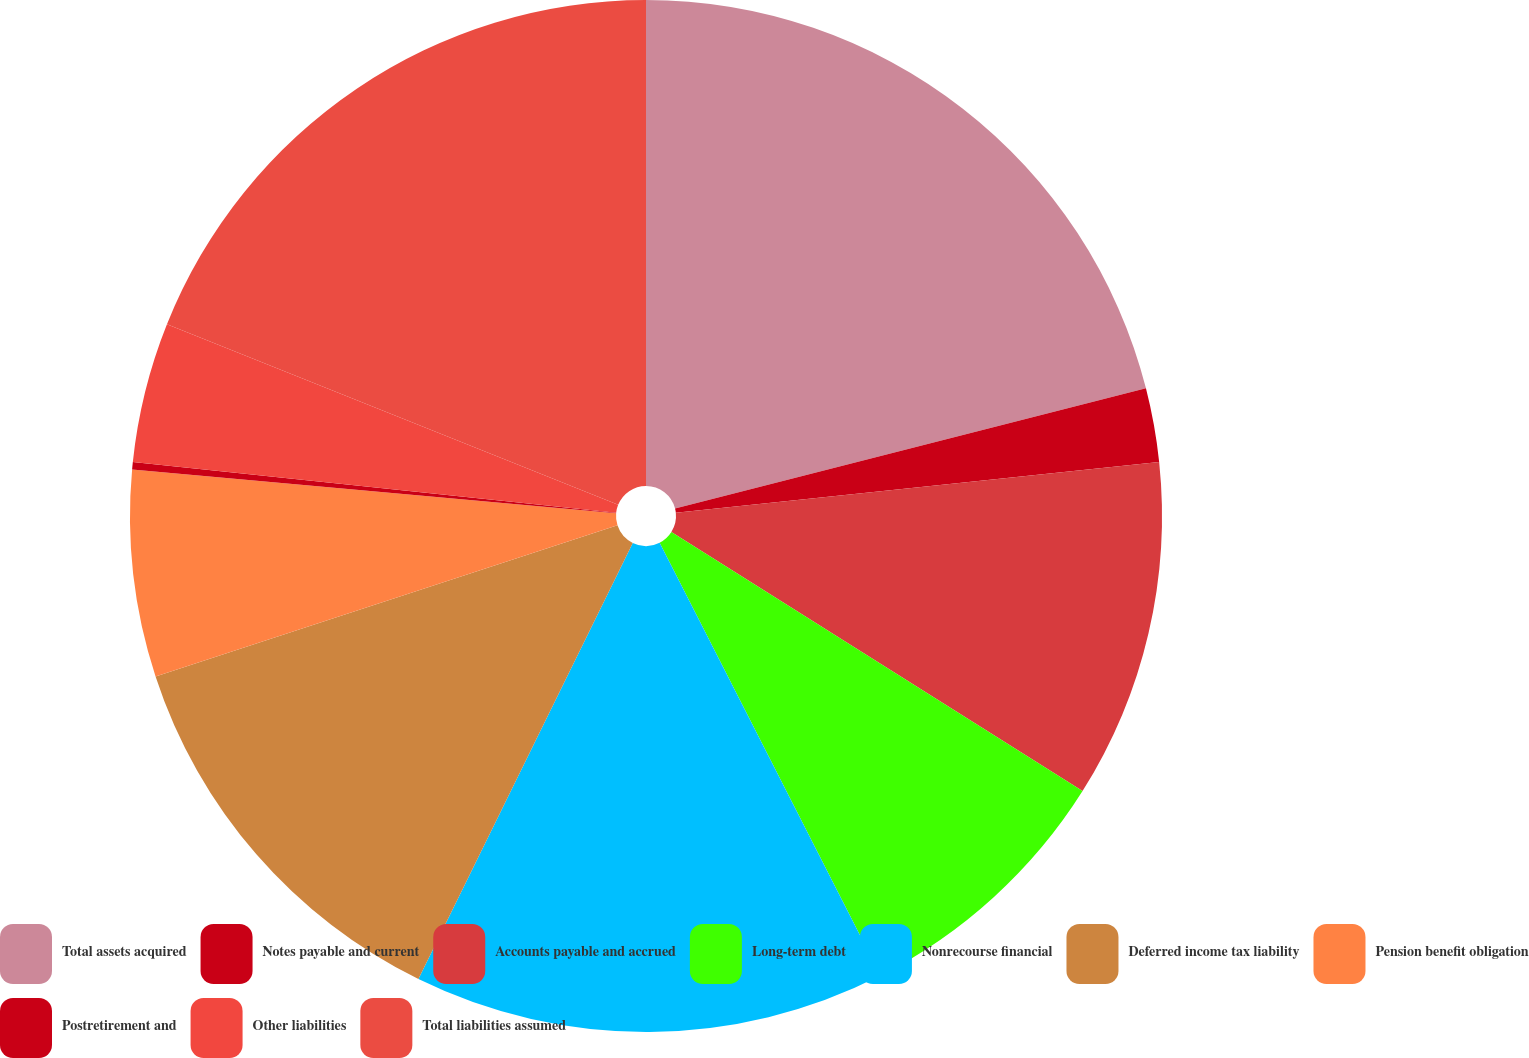Convert chart to OTSL. <chart><loc_0><loc_0><loc_500><loc_500><pie_chart><fcel>Total assets acquired<fcel>Notes payable and current<fcel>Accounts payable and accrued<fcel>Long-term debt<fcel>Nonrecourse financial<fcel>Deferred income tax liability<fcel>Pension benefit obligation<fcel>Postretirement and<fcel>Other liabilities<fcel>Total liabilities assumed<nl><fcel>21.02%<fcel>2.31%<fcel>10.62%<fcel>8.54%<fcel>14.78%<fcel>12.7%<fcel>6.47%<fcel>0.23%<fcel>4.39%<fcel>18.94%<nl></chart> 